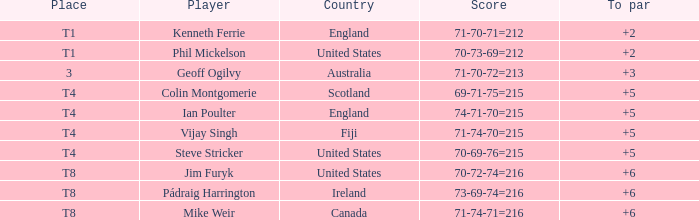What was mike weir's best score in comparison to par? 6.0. 